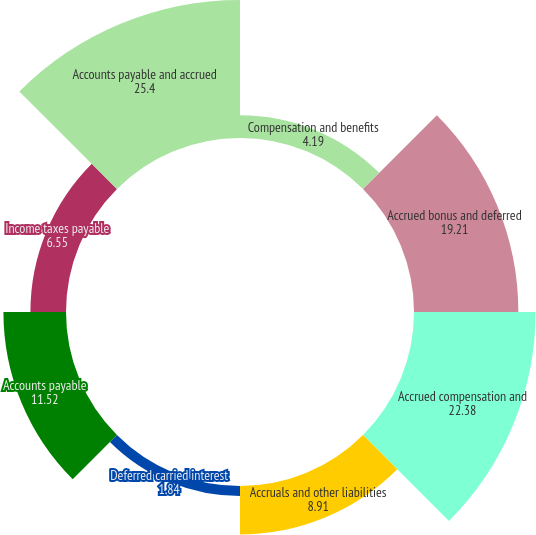Convert chart to OTSL. <chart><loc_0><loc_0><loc_500><loc_500><pie_chart><fcel>Compensation and benefits<fcel>Accrued bonus and deferred<fcel>Accrued compensation and<fcel>Accruals and other liabilities<fcel>Deferred carried interest<fcel>Accounts payable<fcel>Income taxes payable<fcel>Accounts payable and accrued<nl><fcel>4.19%<fcel>19.21%<fcel>22.38%<fcel>8.91%<fcel>1.84%<fcel>11.52%<fcel>6.55%<fcel>25.4%<nl></chart> 